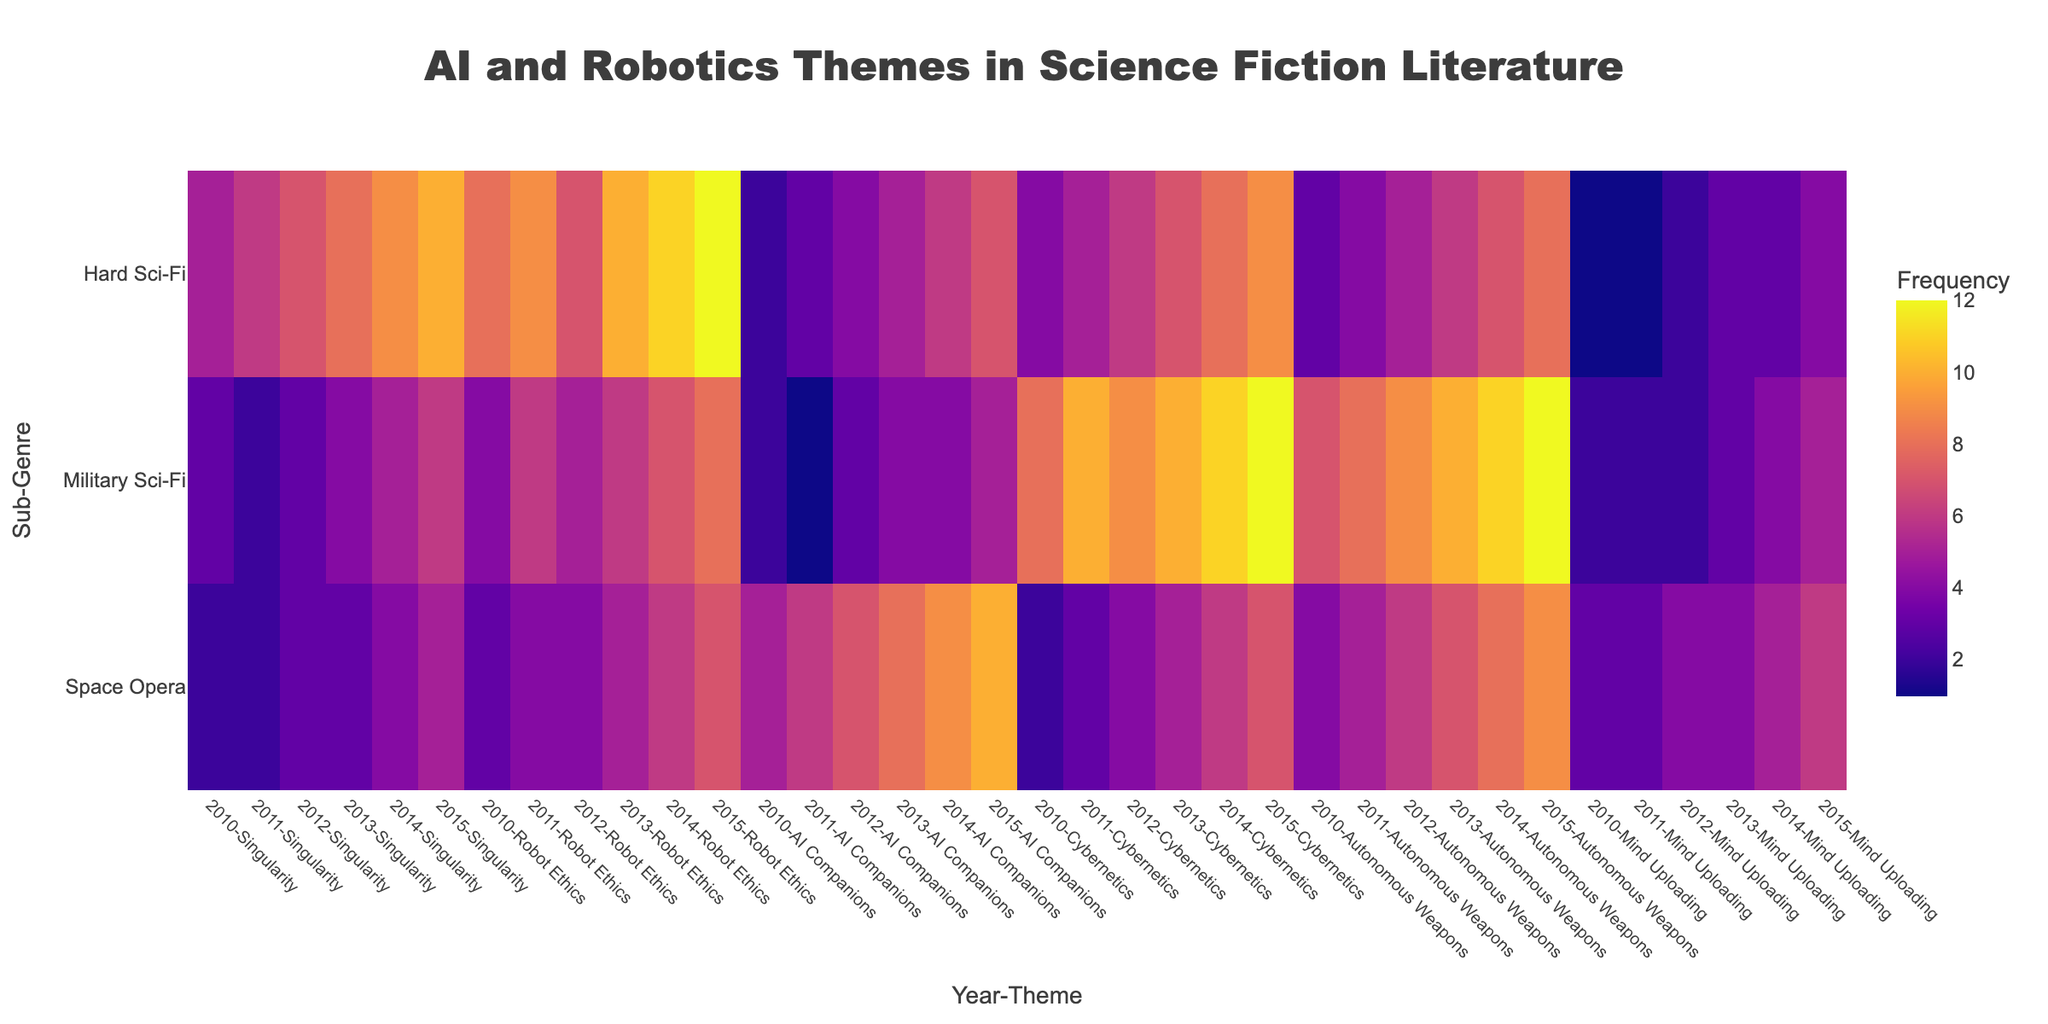What is the title of the figure? The title is displayed prominently at the top of the figure, and it identifies the purpose or content of the heatmap.
Answer: "AI and Robotics Themes in Science Fiction Literature" Which sub-genre shows the highest frequency of 'Cybernetics' themes in 2014? By locating the '2014-Cybernetics' column and evaluating it across all rows (sub-genres), Hard Sci-Fi has the highest value in this column.
Answer: Hard Sci-Fi How did the frequency of 'Autonomous Weapons' in Military Sci-Fi change from 2010 to 2015? To determine the change, find '2010-Autonomous Weapons' and '2015-Autonomous Weapons' for Military Sci-Fi, then calculate the difference. It increased from 7 to 12.
Answer: It increased by 5 Which theme has the lowest frequency in Hard Sci-Fi across all years? For each theme (Singularity, Robot Ethics, AI Companions, Cybernetics, Autonomous Weapons, Mind Uploading), find the lowest value in the Hard Sci-Fi row and identify the corresponding theme. 'Mind Uploading' has the lowest frequency (1 in 2010 and 2011).
Answer: Mind Uploading In which year and sub-genre did 'Robot Ethics' reach its peak frequency? Look for the highest value in the 'Robot Ethics' columns for all years and sub-genres. The peak value is 12, which occurs in Hard Sci-Fi in 2015.
Answer: 2015 in Hard Sci-Fi Which sub-genre had a higher average frequency of 'AI Companions' themes from 2010 to 2015, Space Opera or Military Sci-Fi? Calculate the average frequency for 'AI Companions' in each year from 2010 to 2015 for both Space Opera and Military Sci-Fi, then compare the averages: 
Space Opera: (5+6+7+8+9+10)/6 = 7.5
Military Sci-Fi: (2+1+3+4+4+5)/6 ≈ 3.17
Answer: Space Opera What is the trend of 'Mind Uploading' in Military Sci-Fi from 2010 to 2015? Identify the frequency values for 'Mind Uploading' in Military Sci-Fi for each year and observe the changes: 2010 (2), 2011 (2), 2012 (2), 2013 (3), 2014 (4), 2015 (5). It shows a generally increasing trend.
Answer: Increasing trend Did the frequency of 'Singularity' themes in Hard Sci-Fi increase or decrease every year from 2010 to 2015? Examine the frequency values for 'Singularity' in Hard Sci-Fi from year to year: 2010 (5), 2011 (6), 2012 (7), 2013 (8), 2014 (9), 2015 (10). It increased every year.
Answer: Increase Compare the frequency of 'AI Companions' in Space Opera and Hard Sci-Fi in 2013. Which one is higher? Check the '2013-AI Companions' column for both Space Opera and Hard Sci-Fi: 8 in Space Opera and 5 in Hard Sci-Fi. Space Opera has a higher frequency.
Answer: Space Opera Which sub-genre has the most balanced frequency of various themes in 2015? Calculate the frequency for each theme in all sub-genres for 2015 and see which sub-genre has less variation between the values:
Hard Sci-Fi: [10, 12, 7, 9, 8, 4]
Military Sci-Fi: [6, 8, 5, 12, 12, 5]
Space Opera: [5, 7, 10, 7, 9, 6]
Space Opera seems to have a more balanced distribution (less variation).
Answer: Space Opera 